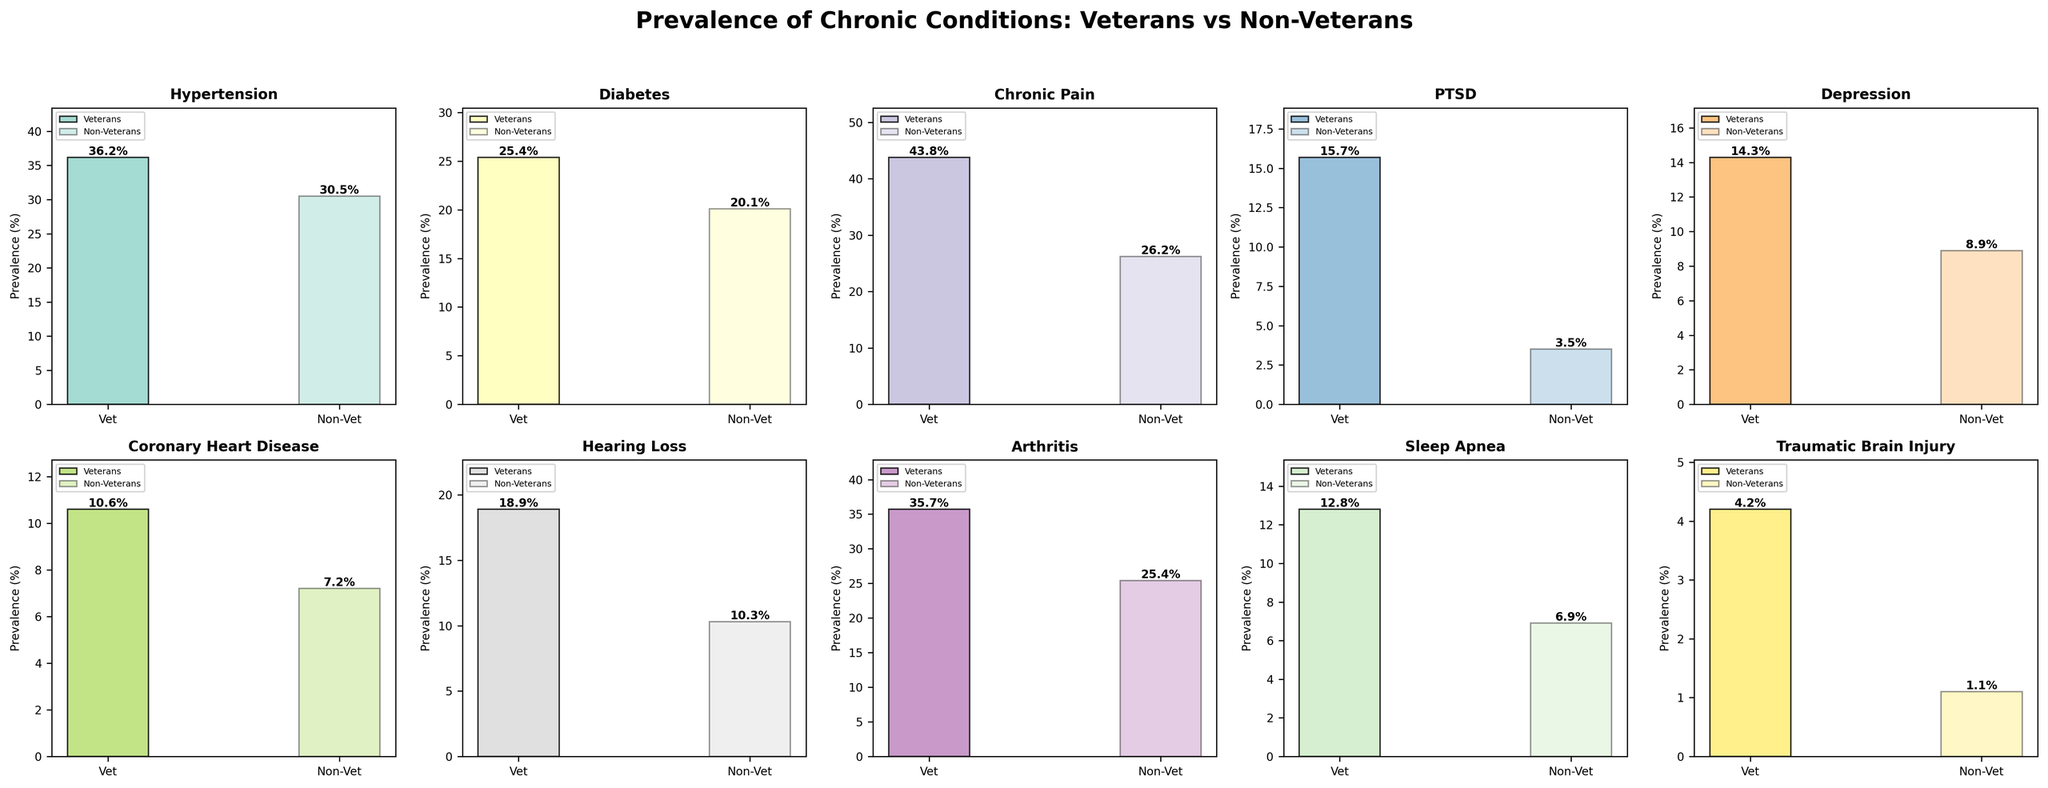What's the prevalence of PTSD in the veteran population? The prevalence of PTSD in the veteran population can be found in the subplot title "PTSD" under the "Veterans" bar.
Answer: 15.7% Which condition shows the largest difference in prevalence between veterans and non-veterans? The condition with the largest difference in prevalence can be determined by comparing the heights of the bars in each subplot, with the largest gap between the veteran and non-veteran bars indicating the largest difference. Chronic Pain has a difference of 17.6% (43.8% veterans vs. 26.2% non-veterans).
Answer: Chronic Pain What is the combined prevalence of hypertension and diabetes in the veteran population? To find the combined prevalence, add the values for hypertension and diabetes for veterans: 36.2 + 25.4 = 61.6%.
Answer: 61.6% How much higher is the prevalence of hearing loss in veterans compared to non-veterans? Subtract the prevalence of hearing loss in non-veterans from the prevalence in veterans: 18.9 - 10.3 = 8.6%.
Answer: 8.6% Which condition has the lowest prevalence in the non-veteran population? The condition with the smallest bar height among all non-veteran subplots indicates the lowest prevalence. Traumatic Brain Injury has the lowest prevalence in the non-veteran population at 1.1%.
Answer: Traumatic Brain Injury What is the average prevalence of arthritis across both populations? To find the average prevalence, add the values for arthritis in veterans and non-veterans and divide by 2: (35.7 + 25.4) / 2 = 30.55%.
Answer: 30.55% Do veterans or non-veterans have a higher prevalence of sleep apnea? By comparing the heights of the bars for sleep apnea, veterans have a prevalence of 12.8% and non-veterans have 6.9%. Therefore, veterans have a higher prevalence.
Answer: Veterans What percentage of veterans suffer from coronary heart disease? The prevalence can be found in the subplot titled "Coronary Heart Disease" under the "Veterans" bar.
Answer: 10.6% In which condition is the prevalence for veterans closest to that of non-veterans? The condition where the difference in bar heights between veterans and non-veterans is the smallest indicates the closest prevalence. For hypertension, veterans show 36.2% and non-veterans 30.5%, a difference of 5.7%, the smallest among all conditions.
Answer: Hypertension 